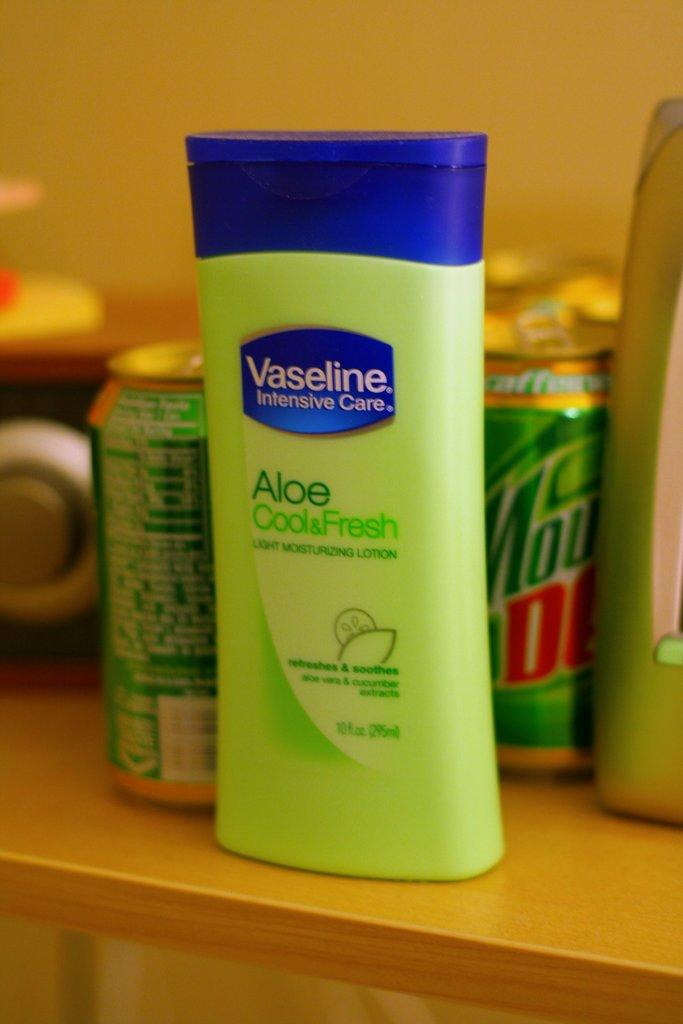What type of product is featured in the image? There is a moisturizer bottle in the image. What else can be seen in the image besides the moisturizer bottle? There are beverage cans in the image. Can you describe the background of the image? The backdrop is blurred, and there are other objects present in the background. What type of vessel is used to serve the eggnog in the image? There is no eggnog or vessel present in the image. How is the whip used in the image? There is no whip present in the image. 